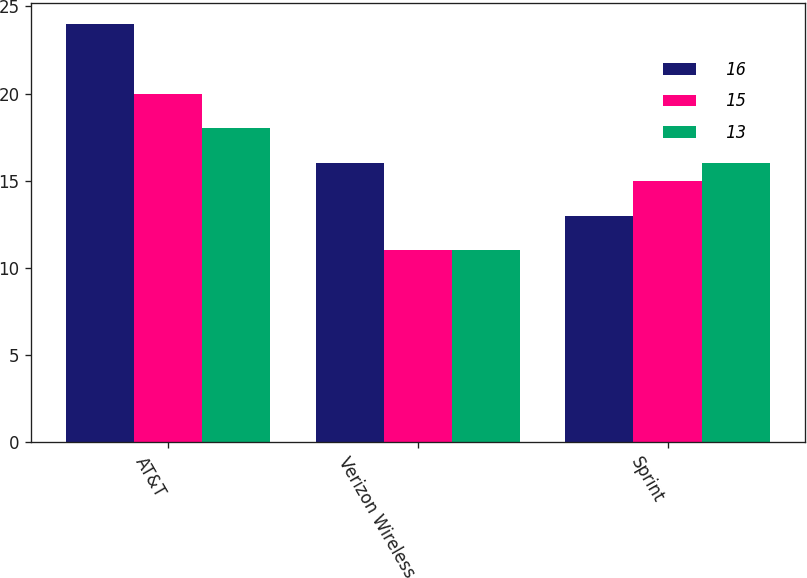Convert chart. <chart><loc_0><loc_0><loc_500><loc_500><stacked_bar_chart><ecel><fcel>AT&T<fcel>Verizon Wireless<fcel>Sprint<nl><fcel>16<fcel>24<fcel>16<fcel>13<nl><fcel>15<fcel>20<fcel>11<fcel>15<nl><fcel>13<fcel>18<fcel>11<fcel>16<nl></chart> 